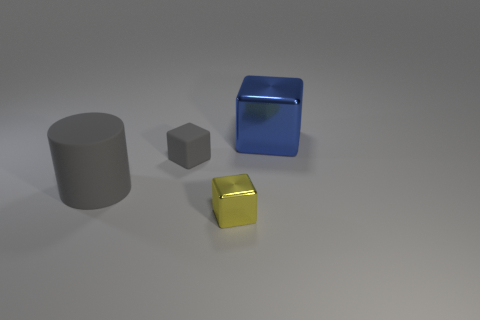What number of other objects are the same size as the matte cube?
Your answer should be very brief. 1. Is the number of rubber cubes in front of the big blue object greater than the number of tiny rubber spheres?
Your response must be concise. Yes. There is a tiny object that is the same color as the big cylinder; what shape is it?
Keep it short and to the point. Cube. How many cylinders are small cyan things or small yellow things?
Your answer should be compact. 0. There is a big object left of the metallic object that is behind the gray matte cylinder; what color is it?
Your answer should be compact. Gray. There is a large matte cylinder; is its color the same as the cube on the left side of the yellow block?
Your response must be concise. Yes. There is a cube that is made of the same material as the large gray cylinder; what is its size?
Offer a very short reply. Small. What size is the matte cylinder that is the same color as the rubber block?
Provide a succinct answer. Large. Do the rubber cylinder and the matte cube have the same color?
Offer a very short reply. Yes. Are there any big matte cylinders that are to the left of the block on the left side of the shiny thing that is in front of the small gray rubber object?
Ensure brevity in your answer.  Yes. 